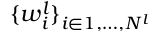<formula> <loc_0><loc_0><loc_500><loc_500>\{ w _ { i } ^ { l } \} _ { i \in 1 , \dots , N ^ { l } }</formula> 